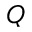Convert formula to latex. <formula><loc_0><loc_0><loc_500><loc_500>Q</formula> 